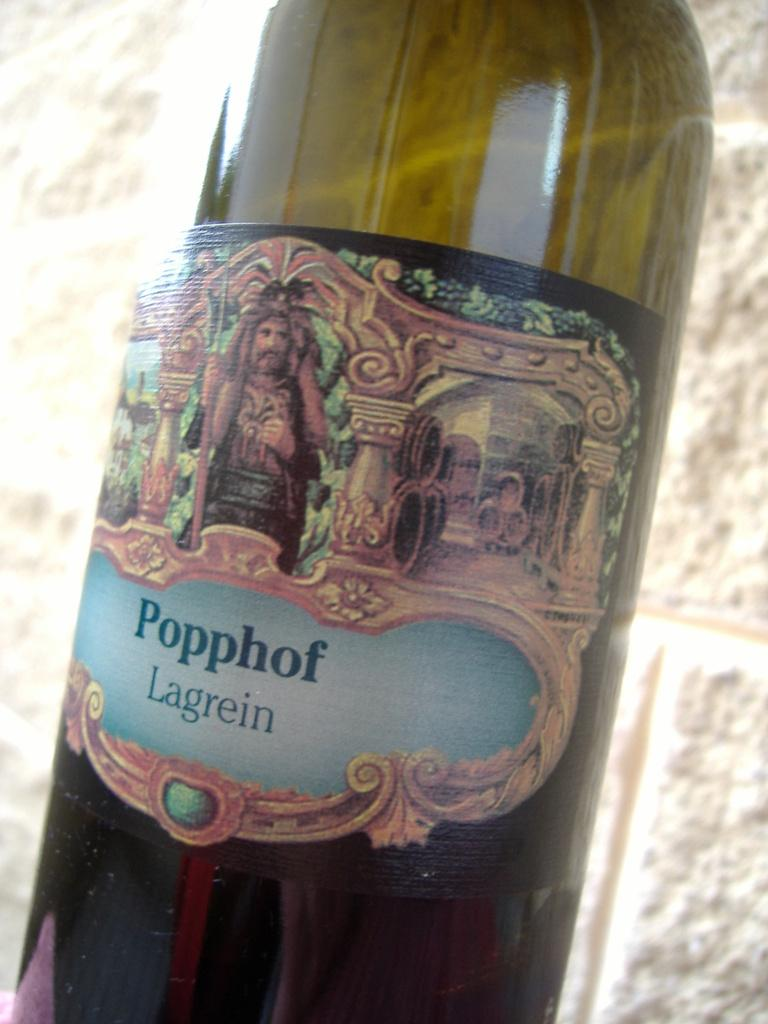Provide a one-sentence caption for the provided image. A bottle of Popphof Lagrein has an antique looking label. 